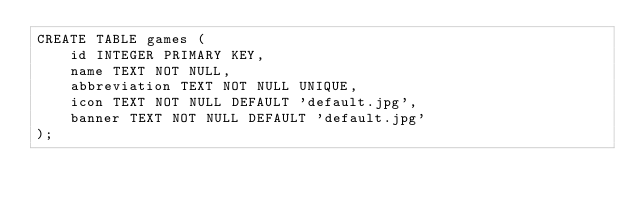<code> <loc_0><loc_0><loc_500><loc_500><_SQL_>CREATE TABLE games (
    id INTEGER PRIMARY KEY,
    name TEXT NOT NULL,
    abbreviation TEXT NOT NULL UNIQUE,
    icon TEXT NOT NULL DEFAULT 'default.jpg',
    banner TEXT NOT NULL DEFAULT 'default.jpg'
);
</code> 